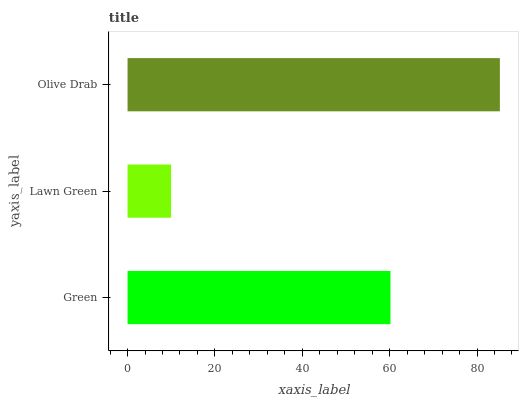Is Lawn Green the minimum?
Answer yes or no. Yes. Is Olive Drab the maximum?
Answer yes or no. Yes. Is Olive Drab the minimum?
Answer yes or no. No. Is Lawn Green the maximum?
Answer yes or no. No. Is Olive Drab greater than Lawn Green?
Answer yes or no. Yes. Is Lawn Green less than Olive Drab?
Answer yes or no. Yes. Is Lawn Green greater than Olive Drab?
Answer yes or no. No. Is Olive Drab less than Lawn Green?
Answer yes or no. No. Is Green the high median?
Answer yes or no. Yes. Is Green the low median?
Answer yes or no. Yes. Is Lawn Green the high median?
Answer yes or no. No. Is Olive Drab the low median?
Answer yes or no. No. 